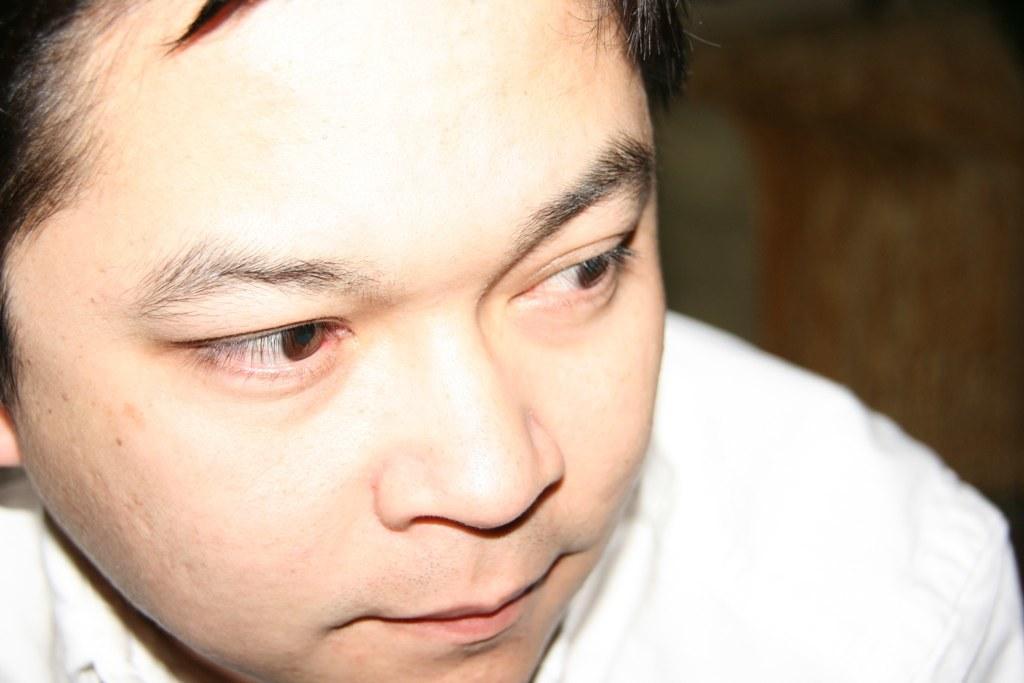How would you summarize this image in a sentence or two? In this image there is a person face. 